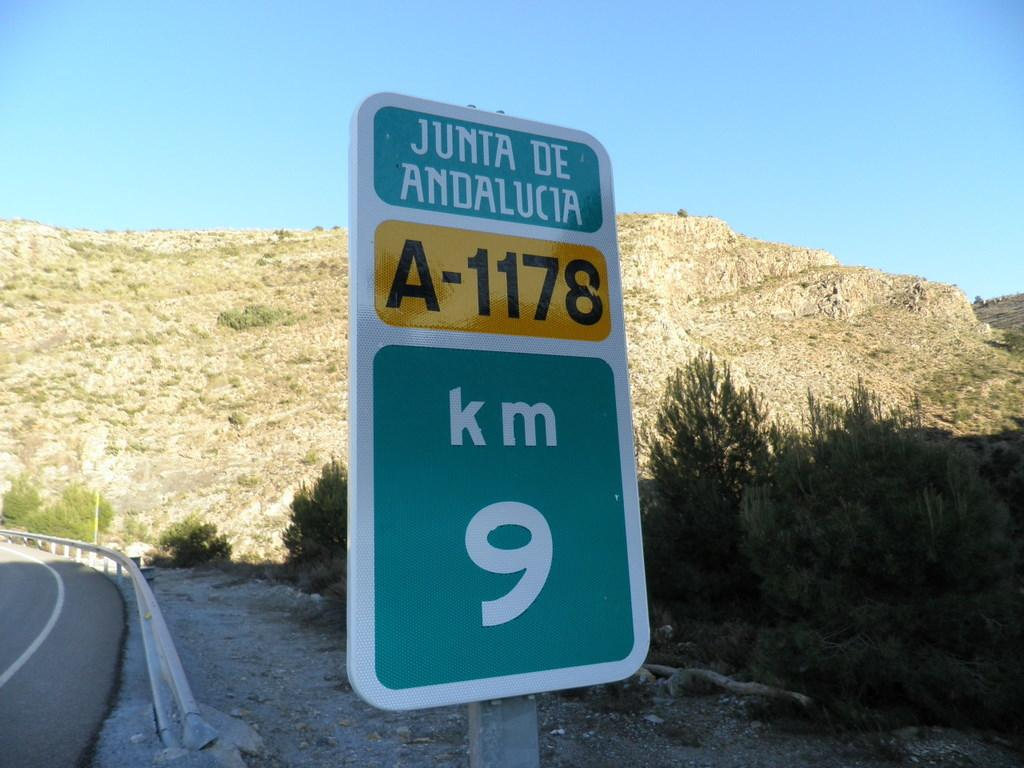<image>
Render a clear and concise summary of the photo. A road sign displays a marker reading 9 kilometers, among other text. 